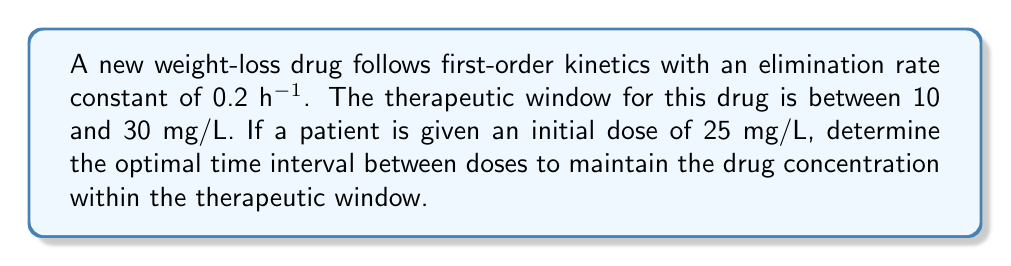Show me your answer to this math problem. To solve this problem, we'll use the first-order kinetics equation and differential equations:

1) The first-order kinetics equation is:
   $$C(t) = C_0 e^{-kt}$$
   where $C(t)$ is the concentration at time $t$, $C_0$ is the initial concentration, $k$ is the elimination rate constant, and $t$ is time.

2) We want to find the time when the concentration reaches the lower limit of the therapeutic window (10 mg/L):
   $$10 = 25 e^{-0.2t}$$

3) Solving for $t$:
   $$\ln(\frac{10}{25}) = -0.2t$$
   $$t = \frac{\ln(2.5)}{0.2} \approx 4.62\text{ hours}$$

4) This means the drug concentration will fall below the therapeutic window after about 4.62 hours.

5) To maintain the concentration within the therapeutic window, we should administer the next dose just before this time.

6) Rounding down to the nearest half-hour for practical dosing, the optimal dosing interval would be 4.5 hours.
Answer: 4.5 hours 